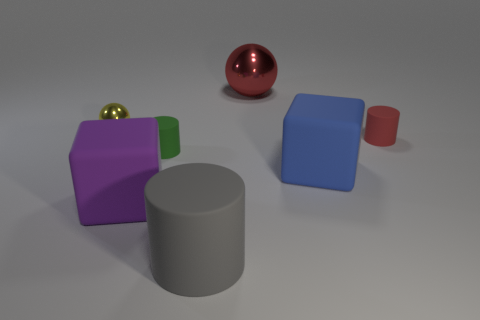Add 1 small red objects. How many objects exist? 8 Subtract all balls. How many objects are left? 5 Subtract all large cylinders. Subtract all big red metal objects. How many objects are left? 5 Add 4 large red metal objects. How many large red metal objects are left? 5 Add 5 rubber blocks. How many rubber blocks exist? 7 Subtract 1 red spheres. How many objects are left? 6 